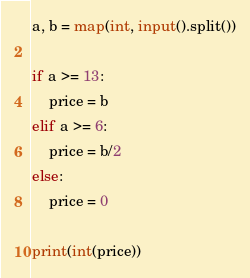<code> <loc_0><loc_0><loc_500><loc_500><_Python_>a, b = map(int, input().split())

if a >= 13:
    price = b
elif a >= 6:
    price = b/2
else:
    price = 0

print(int(price))</code> 